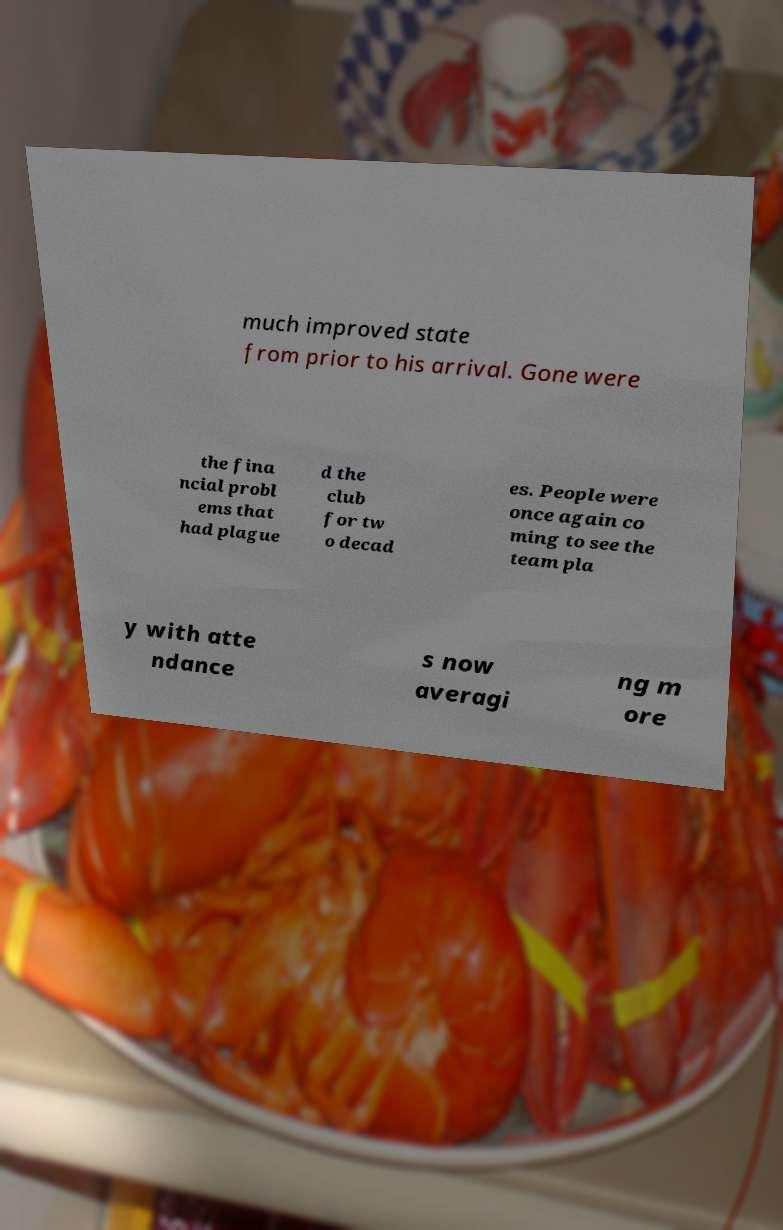For documentation purposes, I need the text within this image transcribed. Could you provide that? much improved state from prior to his arrival. Gone were the fina ncial probl ems that had plague d the club for tw o decad es. People were once again co ming to see the team pla y with atte ndance s now averagi ng m ore 